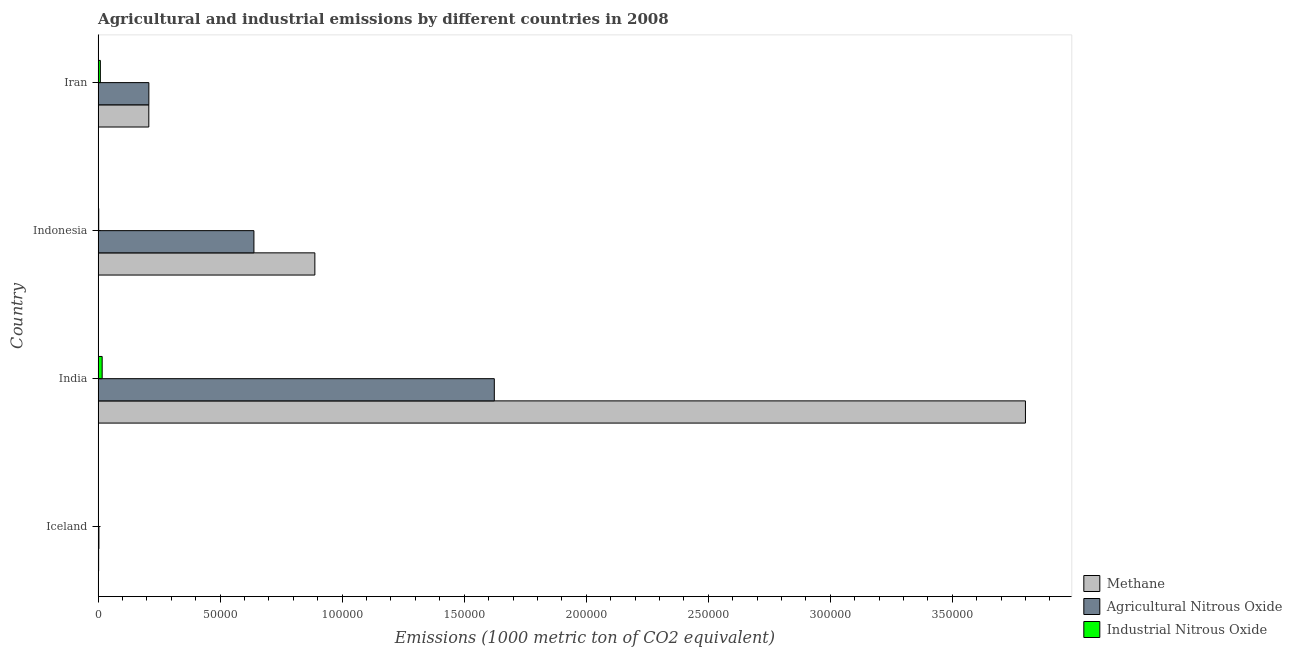How many different coloured bars are there?
Give a very brief answer. 3. Are the number of bars per tick equal to the number of legend labels?
Give a very brief answer. Yes. How many bars are there on the 1st tick from the top?
Your response must be concise. 3. What is the label of the 3rd group of bars from the top?
Make the answer very short. India. In how many cases, is the number of bars for a given country not equal to the number of legend labels?
Your response must be concise. 0. What is the amount of methane emissions in Iran?
Offer a terse response. 2.08e+04. Across all countries, what is the maximum amount of agricultural nitrous oxide emissions?
Offer a very short reply. 1.62e+05. Across all countries, what is the minimum amount of methane emissions?
Your answer should be compact. 209.2. In which country was the amount of industrial nitrous oxide emissions maximum?
Offer a terse response. India. In which country was the amount of methane emissions minimum?
Provide a succinct answer. Iceland. What is the total amount of industrial nitrous oxide emissions in the graph?
Provide a succinct answer. 2836. What is the difference between the amount of industrial nitrous oxide emissions in Iceland and that in India?
Offer a terse response. -1643.1. What is the difference between the amount of agricultural nitrous oxide emissions in Iceland and the amount of methane emissions in India?
Make the answer very short. -3.80e+05. What is the average amount of agricultural nitrous oxide emissions per country?
Provide a short and direct response. 6.18e+04. What is the difference between the amount of agricultural nitrous oxide emissions and amount of industrial nitrous oxide emissions in Indonesia?
Your response must be concise. 6.36e+04. In how many countries, is the amount of industrial nitrous oxide emissions greater than 320000 metric ton?
Offer a very short reply. 0. What is the ratio of the amount of agricultural nitrous oxide emissions in India to that in Iran?
Give a very brief answer. 7.81. Is the amount of industrial nitrous oxide emissions in India less than that in Indonesia?
Provide a short and direct response. No. What is the difference between the highest and the second highest amount of agricultural nitrous oxide emissions?
Ensure brevity in your answer.  9.85e+04. What is the difference between the highest and the lowest amount of methane emissions?
Keep it short and to the point. 3.80e+05. What does the 1st bar from the top in India represents?
Provide a short and direct response. Industrial Nitrous Oxide. What does the 3rd bar from the bottom in Iran represents?
Keep it short and to the point. Industrial Nitrous Oxide. Are all the bars in the graph horizontal?
Offer a terse response. Yes. What is the difference between two consecutive major ticks on the X-axis?
Your answer should be compact. 5.00e+04. Does the graph contain grids?
Give a very brief answer. No. Where does the legend appear in the graph?
Provide a succinct answer. Bottom right. What is the title of the graph?
Provide a succinct answer. Agricultural and industrial emissions by different countries in 2008. What is the label or title of the X-axis?
Your answer should be very brief. Emissions (1000 metric ton of CO2 equivalent). What is the label or title of the Y-axis?
Give a very brief answer. Country. What is the Emissions (1000 metric ton of CO2 equivalent) of Methane in Iceland?
Give a very brief answer. 209.2. What is the Emissions (1000 metric ton of CO2 equivalent) in Agricultural Nitrous Oxide in Iceland?
Keep it short and to the point. 330.8. What is the Emissions (1000 metric ton of CO2 equivalent) of Industrial Nitrous Oxide in Iceland?
Ensure brevity in your answer.  16.7. What is the Emissions (1000 metric ton of CO2 equivalent) in Methane in India?
Your response must be concise. 3.80e+05. What is the Emissions (1000 metric ton of CO2 equivalent) of Agricultural Nitrous Oxide in India?
Your response must be concise. 1.62e+05. What is the Emissions (1000 metric ton of CO2 equivalent) of Industrial Nitrous Oxide in India?
Provide a succinct answer. 1659.8. What is the Emissions (1000 metric ton of CO2 equivalent) of Methane in Indonesia?
Offer a very short reply. 8.88e+04. What is the Emissions (1000 metric ton of CO2 equivalent) in Agricultural Nitrous Oxide in Indonesia?
Your answer should be very brief. 6.38e+04. What is the Emissions (1000 metric ton of CO2 equivalent) of Industrial Nitrous Oxide in Indonesia?
Your answer should be compact. 243.3. What is the Emissions (1000 metric ton of CO2 equivalent) in Methane in Iran?
Your response must be concise. 2.08e+04. What is the Emissions (1000 metric ton of CO2 equivalent) of Agricultural Nitrous Oxide in Iran?
Make the answer very short. 2.08e+04. What is the Emissions (1000 metric ton of CO2 equivalent) of Industrial Nitrous Oxide in Iran?
Provide a short and direct response. 916.2. Across all countries, what is the maximum Emissions (1000 metric ton of CO2 equivalent) in Methane?
Give a very brief answer. 3.80e+05. Across all countries, what is the maximum Emissions (1000 metric ton of CO2 equivalent) of Agricultural Nitrous Oxide?
Your answer should be very brief. 1.62e+05. Across all countries, what is the maximum Emissions (1000 metric ton of CO2 equivalent) in Industrial Nitrous Oxide?
Keep it short and to the point. 1659.8. Across all countries, what is the minimum Emissions (1000 metric ton of CO2 equivalent) of Methane?
Offer a very short reply. 209.2. Across all countries, what is the minimum Emissions (1000 metric ton of CO2 equivalent) of Agricultural Nitrous Oxide?
Make the answer very short. 330.8. Across all countries, what is the minimum Emissions (1000 metric ton of CO2 equivalent) of Industrial Nitrous Oxide?
Provide a short and direct response. 16.7. What is the total Emissions (1000 metric ton of CO2 equivalent) in Methane in the graph?
Ensure brevity in your answer.  4.90e+05. What is the total Emissions (1000 metric ton of CO2 equivalent) of Agricultural Nitrous Oxide in the graph?
Offer a terse response. 2.47e+05. What is the total Emissions (1000 metric ton of CO2 equivalent) in Industrial Nitrous Oxide in the graph?
Give a very brief answer. 2836. What is the difference between the Emissions (1000 metric ton of CO2 equivalent) in Methane in Iceland and that in India?
Your response must be concise. -3.80e+05. What is the difference between the Emissions (1000 metric ton of CO2 equivalent) of Agricultural Nitrous Oxide in Iceland and that in India?
Ensure brevity in your answer.  -1.62e+05. What is the difference between the Emissions (1000 metric ton of CO2 equivalent) in Industrial Nitrous Oxide in Iceland and that in India?
Ensure brevity in your answer.  -1643.1. What is the difference between the Emissions (1000 metric ton of CO2 equivalent) of Methane in Iceland and that in Indonesia?
Give a very brief answer. -8.86e+04. What is the difference between the Emissions (1000 metric ton of CO2 equivalent) of Agricultural Nitrous Oxide in Iceland and that in Indonesia?
Give a very brief answer. -6.35e+04. What is the difference between the Emissions (1000 metric ton of CO2 equivalent) in Industrial Nitrous Oxide in Iceland and that in Indonesia?
Offer a terse response. -226.6. What is the difference between the Emissions (1000 metric ton of CO2 equivalent) of Methane in Iceland and that in Iran?
Provide a short and direct response. -2.06e+04. What is the difference between the Emissions (1000 metric ton of CO2 equivalent) of Agricultural Nitrous Oxide in Iceland and that in Iran?
Offer a terse response. -2.05e+04. What is the difference between the Emissions (1000 metric ton of CO2 equivalent) in Industrial Nitrous Oxide in Iceland and that in Iran?
Provide a short and direct response. -899.5. What is the difference between the Emissions (1000 metric ton of CO2 equivalent) of Methane in India and that in Indonesia?
Ensure brevity in your answer.  2.91e+05. What is the difference between the Emissions (1000 metric ton of CO2 equivalent) in Agricultural Nitrous Oxide in India and that in Indonesia?
Your answer should be compact. 9.85e+04. What is the difference between the Emissions (1000 metric ton of CO2 equivalent) of Industrial Nitrous Oxide in India and that in Indonesia?
Ensure brevity in your answer.  1416.5. What is the difference between the Emissions (1000 metric ton of CO2 equivalent) of Methane in India and that in Iran?
Your response must be concise. 3.59e+05. What is the difference between the Emissions (1000 metric ton of CO2 equivalent) of Agricultural Nitrous Oxide in India and that in Iran?
Ensure brevity in your answer.  1.42e+05. What is the difference between the Emissions (1000 metric ton of CO2 equivalent) of Industrial Nitrous Oxide in India and that in Iran?
Offer a very short reply. 743.6. What is the difference between the Emissions (1000 metric ton of CO2 equivalent) in Methane in Indonesia and that in Iran?
Offer a very short reply. 6.80e+04. What is the difference between the Emissions (1000 metric ton of CO2 equivalent) in Agricultural Nitrous Oxide in Indonesia and that in Iran?
Give a very brief answer. 4.31e+04. What is the difference between the Emissions (1000 metric ton of CO2 equivalent) in Industrial Nitrous Oxide in Indonesia and that in Iran?
Provide a short and direct response. -672.9. What is the difference between the Emissions (1000 metric ton of CO2 equivalent) of Methane in Iceland and the Emissions (1000 metric ton of CO2 equivalent) of Agricultural Nitrous Oxide in India?
Provide a succinct answer. -1.62e+05. What is the difference between the Emissions (1000 metric ton of CO2 equivalent) in Methane in Iceland and the Emissions (1000 metric ton of CO2 equivalent) in Industrial Nitrous Oxide in India?
Offer a very short reply. -1450.6. What is the difference between the Emissions (1000 metric ton of CO2 equivalent) of Agricultural Nitrous Oxide in Iceland and the Emissions (1000 metric ton of CO2 equivalent) of Industrial Nitrous Oxide in India?
Give a very brief answer. -1329. What is the difference between the Emissions (1000 metric ton of CO2 equivalent) of Methane in Iceland and the Emissions (1000 metric ton of CO2 equivalent) of Agricultural Nitrous Oxide in Indonesia?
Keep it short and to the point. -6.36e+04. What is the difference between the Emissions (1000 metric ton of CO2 equivalent) in Methane in Iceland and the Emissions (1000 metric ton of CO2 equivalent) in Industrial Nitrous Oxide in Indonesia?
Make the answer very short. -34.1. What is the difference between the Emissions (1000 metric ton of CO2 equivalent) in Agricultural Nitrous Oxide in Iceland and the Emissions (1000 metric ton of CO2 equivalent) in Industrial Nitrous Oxide in Indonesia?
Make the answer very short. 87.5. What is the difference between the Emissions (1000 metric ton of CO2 equivalent) in Methane in Iceland and the Emissions (1000 metric ton of CO2 equivalent) in Agricultural Nitrous Oxide in Iran?
Your answer should be very brief. -2.06e+04. What is the difference between the Emissions (1000 metric ton of CO2 equivalent) of Methane in Iceland and the Emissions (1000 metric ton of CO2 equivalent) of Industrial Nitrous Oxide in Iran?
Provide a succinct answer. -707. What is the difference between the Emissions (1000 metric ton of CO2 equivalent) in Agricultural Nitrous Oxide in Iceland and the Emissions (1000 metric ton of CO2 equivalent) in Industrial Nitrous Oxide in Iran?
Provide a succinct answer. -585.4. What is the difference between the Emissions (1000 metric ton of CO2 equivalent) of Methane in India and the Emissions (1000 metric ton of CO2 equivalent) of Agricultural Nitrous Oxide in Indonesia?
Provide a short and direct response. 3.16e+05. What is the difference between the Emissions (1000 metric ton of CO2 equivalent) in Methane in India and the Emissions (1000 metric ton of CO2 equivalent) in Industrial Nitrous Oxide in Indonesia?
Your answer should be very brief. 3.80e+05. What is the difference between the Emissions (1000 metric ton of CO2 equivalent) of Agricultural Nitrous Oxide in India and the Emissions (1000 metric ton of CO2 equivalent) of Industrial Nitrous Oxide in Indonesia?
Your answer should be very brief. 1.62e+05. What is the difference between the Emissions (1000 metric ton of CO2 equivalent) of Methane in India and the Emissions (1000 metric ton of CO2 equivalent) of Agricultural Nitrous Oxide in Iran?
Ensure brevity in your answer.  3.59e+05. What is the difference between the Emissions (1000 metric ton of CO2 equivalent) in Methane in India and the Emissions (1000 metric ton of CO2 equivalent) in Industrial Nitrous Oxide in Iran?
Ensure brevity in your answer.  3.79e+05. What is the difference between the Emissions (1000 metric ton of CO2 equivalent) of Agricultural Nitrous Oxide in India and the Emissions (1000 metric ton of CO2 equivalent) of Industrial Nitrous Oxide in Iran?
Provide a succinct answer. 1.61e+05. What is the difference between the Emissions (1000 metric ton of CO2 equivalent) in Methane in Indonesia and the Emissions (1000 metric ton of CO2 equivalent) in Agricultural Nitrous Oxide in Iran?
Keep it short and to the point. 6.80e+04. What is the difference between the Emissions (1000 metric ton of CO2 equivalent) of Methane in Indonesia and the Emissions (1000 metric ton of CO2 equivalent) of Industrial Nitrous Oxide in Iran?
Offer a very short reply. 8.79e+04. What is the difference between the Emissions (1000 metric ton of CO2 equivalent) of Agricultural Nitrous Oxide in Indonesia and the Emissions (1000 metric ton of CO2 equivalent) of Industrial Nitrous Oxide in Iran?
Provide a short and direct response. 6.29e+04. What is the average Emissions (1000 metric ton of CO2 equivalent) in Methane per country?
Your answer should be very brief. 1.22e+05. What is the average Emissions (1000 metric ton of CO2 equivalent) of Agricultural Nitrous Oxide per country?
Provide a succinct answer. 6.18e+04. What is the average Emissions (1000 metric ton of CO2 equivalent) of Industrial Nitrous Oxide per country?
Provide a succinct answer. 709. What is the difference between the Emissions (1000 metric ton of CO2 equivalent) of Methane and Emissions (1000 metric ton of CO2 equivalent) of Agricultural Nitrous Oxide in Iceland?
Offer a terse response. -121.6. What is the difference between the Emissions (1000 metric ton of CO2 equivalent) of Methane and Emissions (1000 metric ton of CO2 equivalent) of Industrial Nitrous Oxide in Iceland?
Your response must be concise. 192.5. What is the difference between the Emissions (1000 metric ton of CO2 equivalent) in Agricultural Nitrous Oxide and Emissions (1000 metric ton of CO2 equivalent) in Industrial Nitrous Oxide in Iceland?
Make the answer very short. 314.1. What is the difference between the Emissions (1000 metric ton of CO2 equivalent) in Methane and Emissions (1000 metric ton of CO2 equivalent) in Agricultural Nitrous Oxide in India?
Make the answer very short. 2.18e+05. What is the difference between the Emissions (1000 metric ton of CO2 equivalent) of Methane and Emissions (1000 metric ton of CO2 equivalent) of Industrial Nitrous Oxide in India?
Offer a terse response. 3.78e+05. What is the difference between the Emissions (1000 metric ton of CO2 equivalent) in Agricultural Nitrous Oxide and Emissions (1000 metric ton of CO2 equivalent) in Industrial Nitrous Oxide in India?
Offer a very short reply. 1.61e+05. What is the difference between the Emissions (1000 metric ton of CO2 equivalent) in Methane and Emissions (1000 metric ton of CO2 equivalent) in Agricultural Nitrous Oxide in Indonesia?
Give a very brief answer. 2.50e+04. What is the difference between the Emissions (1000 metric ton of CO2 equivalent) of Methane and Emissions (1000 metric ton of CO2 equivalent) of Industrial Nitrous Oxide in Indonesia?
Provide a short and direct response. 8.86e+04. What is the difference between the Emissions (1000 metric ton of CO2 equivalent) in Agricultural Nitrous Oxide and Emissions (1000 metric ton of CO2 equivalent) in Industrial Nitrous Oxide in Indonesia?
Your answer should be very brief. 6.36e+04. What is the difference between the Emissions (1000 metric ton of CO2 equivalent) of Methane and Emissions (1000 metric ton of CO2 equivalent) of Industrial Nitrous Oxide in Iran?
Your answer should be very brief. 1.99e+04. What is the difference between the Emissions (1000 metric ton of CO2 equivalent) of Agricultural Nitrous Oxide and Emissions (1000 metric ton of CO2 equivalent) of Industrial Nitrous Oxide in Iran?
Provide a short and direct response. 1.99e+04. What is the ratio of the Emissions (1000 metric ton of CO2 equivalent) in Methane in Iceland to that in India?
Make the answer very short. 0. What is the ratio of the Emissions (1000 metric ton of CO2 equivalent) of Agricultural Nitrous Oxide in Iceland to that in India?
Provide a succinct answer. 0. What is the ratio of the Emissions (1000 metric ton of CO2 equivalent) of Industrial Nitrous Oxide in Iceland to that in India?
Offer a very short reply. 0.01. What is the ratio of the Emissions (1000 metric ton of CO2 equivalent) of Methane in Iceland to that in Indonesia?
Provide a succinct answer. 0. What is the ratio of the Emissions (1000 metric ton of CO2 equivalent) in Agricultural Nitrous Oxide in Iceland to that in Indonesia?
Offer a very short reply. 0.01. What is the ratio of the Emissions (1000 metric ton of CO2 equivalent) of Industrial Nitrous Oxide in Iceland to that in Indonesia?
Provide a succinct answer. 0.07. What is the ratio of the Emissions (1000 metric ton of CO2 equivalent) of Methane in Iceland to that in Iran?
Your response must be concise. 0.01. What is the ratio of the Emissions (1000 metric ton of CO2 equivalent) of Agricultural Nitrous Oxide in Iceland to that in Iran?
Ensure brevity in your answer.  0.02. What is the ratio of the Emissions (1000 metric ton of CO2 equivalent) in Industrial Nitrous Oxide in Iceland to that in Iran?
Your answer should be very brief. 0.02. What is the ratio of the Emissions (1000 metric ton of CO2 equivalent) of Methane in India to that in Indonesia?
Offer a terse response. 4.28. What is the ratio of the Emissions (1000 metric ton of CO2 equivalent) of Agricultural Nitrous Oxide in India to that in Indonesia?
Your answer should be compact. 2.54. What is the ratio of the Emissions (1000 metric ton of CO2 equivalent) in Industrial Nitrous Oxide in India to that in Indonesia?
Your response must be concise. 6.82. What is the ratio of the Emissions (1000 metric ton of CO2 equivalent) in Methane in India to that in Iran?
Your answer should be compact. 18.29. What is the ratio of the Emissions (1000 metric ton of CO2 equivalent) in Agricultural Nitrous Oxide in India to that in Iran?
Keep it short and to the point. 7.81. What is the ratio of the Emissions (1000 metric ton of CO2 equivalent) of Industrial Nitrous Oxide in India to that in Iran?
Ensure brevity in your answer.  1.81. What is the ratio of the Emissions (1000 metric ton of CO2 equivalent) of Methane in Indonesia to that in Iran?
Offer a very short reply. 4.27. What is the ratio of the Emissions (1000 metric ton of CO2 equivalent) in Agricultural Nitrous Oxide in Indonesia to that in Iran?
Ensure brevity in your answer.  3.07. What is the ratio of the Emissions (1000 metric ton of CO2 equivalent) in Industrial Nitrous Oxide in Indonesia to that in Iran?
Ensure brevity in your answer.  0.27. What is the difference between the highest and the second highest Emissions (1000 metric ton of CO2 equivalent) in Methane?
Keep it short and to the point. 2.91e+05. What is the difference between the highest and the second highest Emissions (1000 metric ton of CO2 equivalent) of Agricultural Nitrous Oxide?
Offer a very short reply. 9.85e+04. What is the difference between the highest and the second highest Emissions (1000 metric ton of CO2 equivalent) of Industrial Nitrous Oxide?
Your answer should be very brief. 743.6. What is the difference between the highest and the lowest Emissions (1000 metric ton of CO2 equivalent) in Methane?
Ensure brevity in your answer.  3.80e+05. What is the difference between the highest and the lowest Emissions (1000 metric ton of CO2 equivalent) in Agricultural Nitrous Oxide?
Make the answer very short. 1.62e+05. What is the difference between the highest and the lowest Emissions (1000 metric ton of CO2 equivalent) of Industrial Nitrous Oxide?
Keep it short and to the point. 1643.1. 